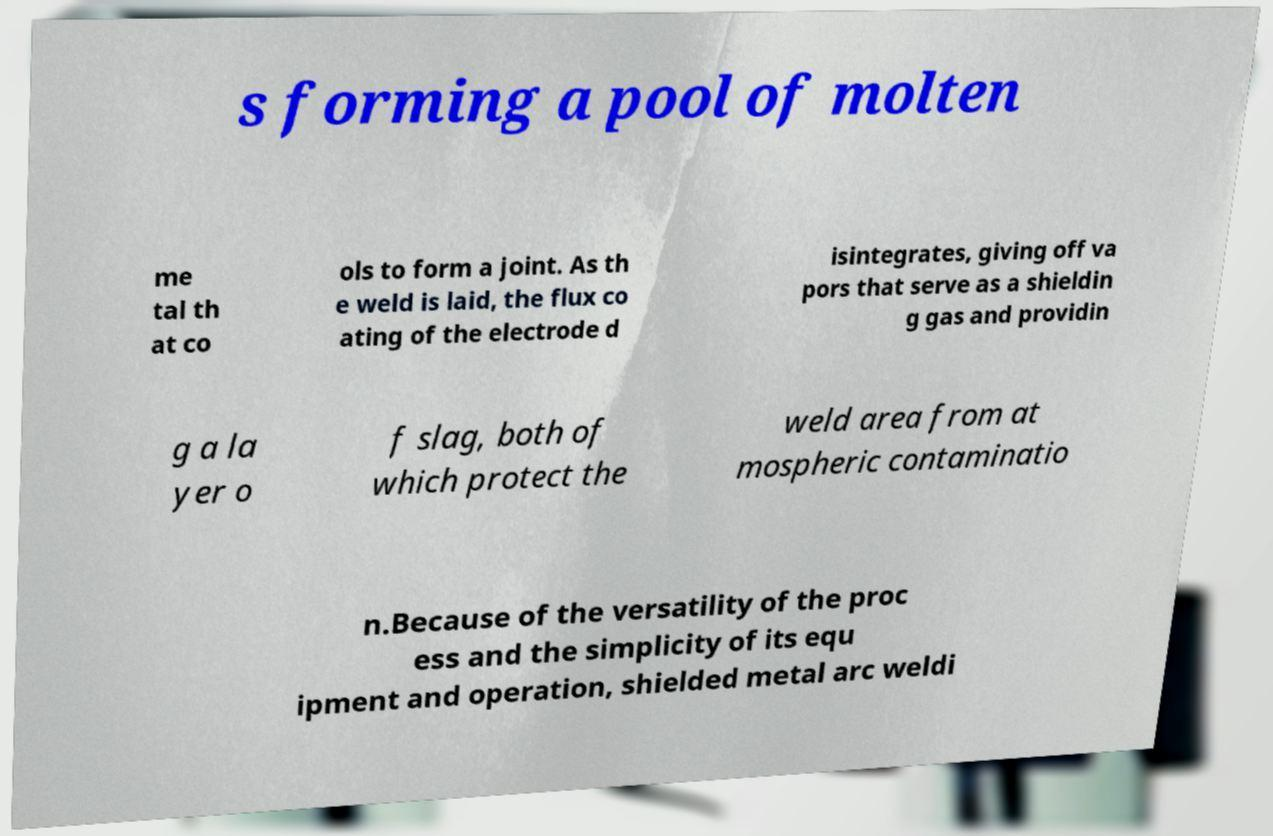Could you assist in decoding the text presented in this image and type it out clearly? s forming a pool of molten me tal th at co ols to form a joint. As th e weld is laid, the flux co ating of the electrode d isintegrates, giving off va pors that serve as a shieldin g gas and providin g a la yer o f slag, both of which protect the weld area from at mospheric contaminatio n.Because of the versatility of the proc ess and the simplicity of its equ ipment and operation, shielded metal arc weldi 